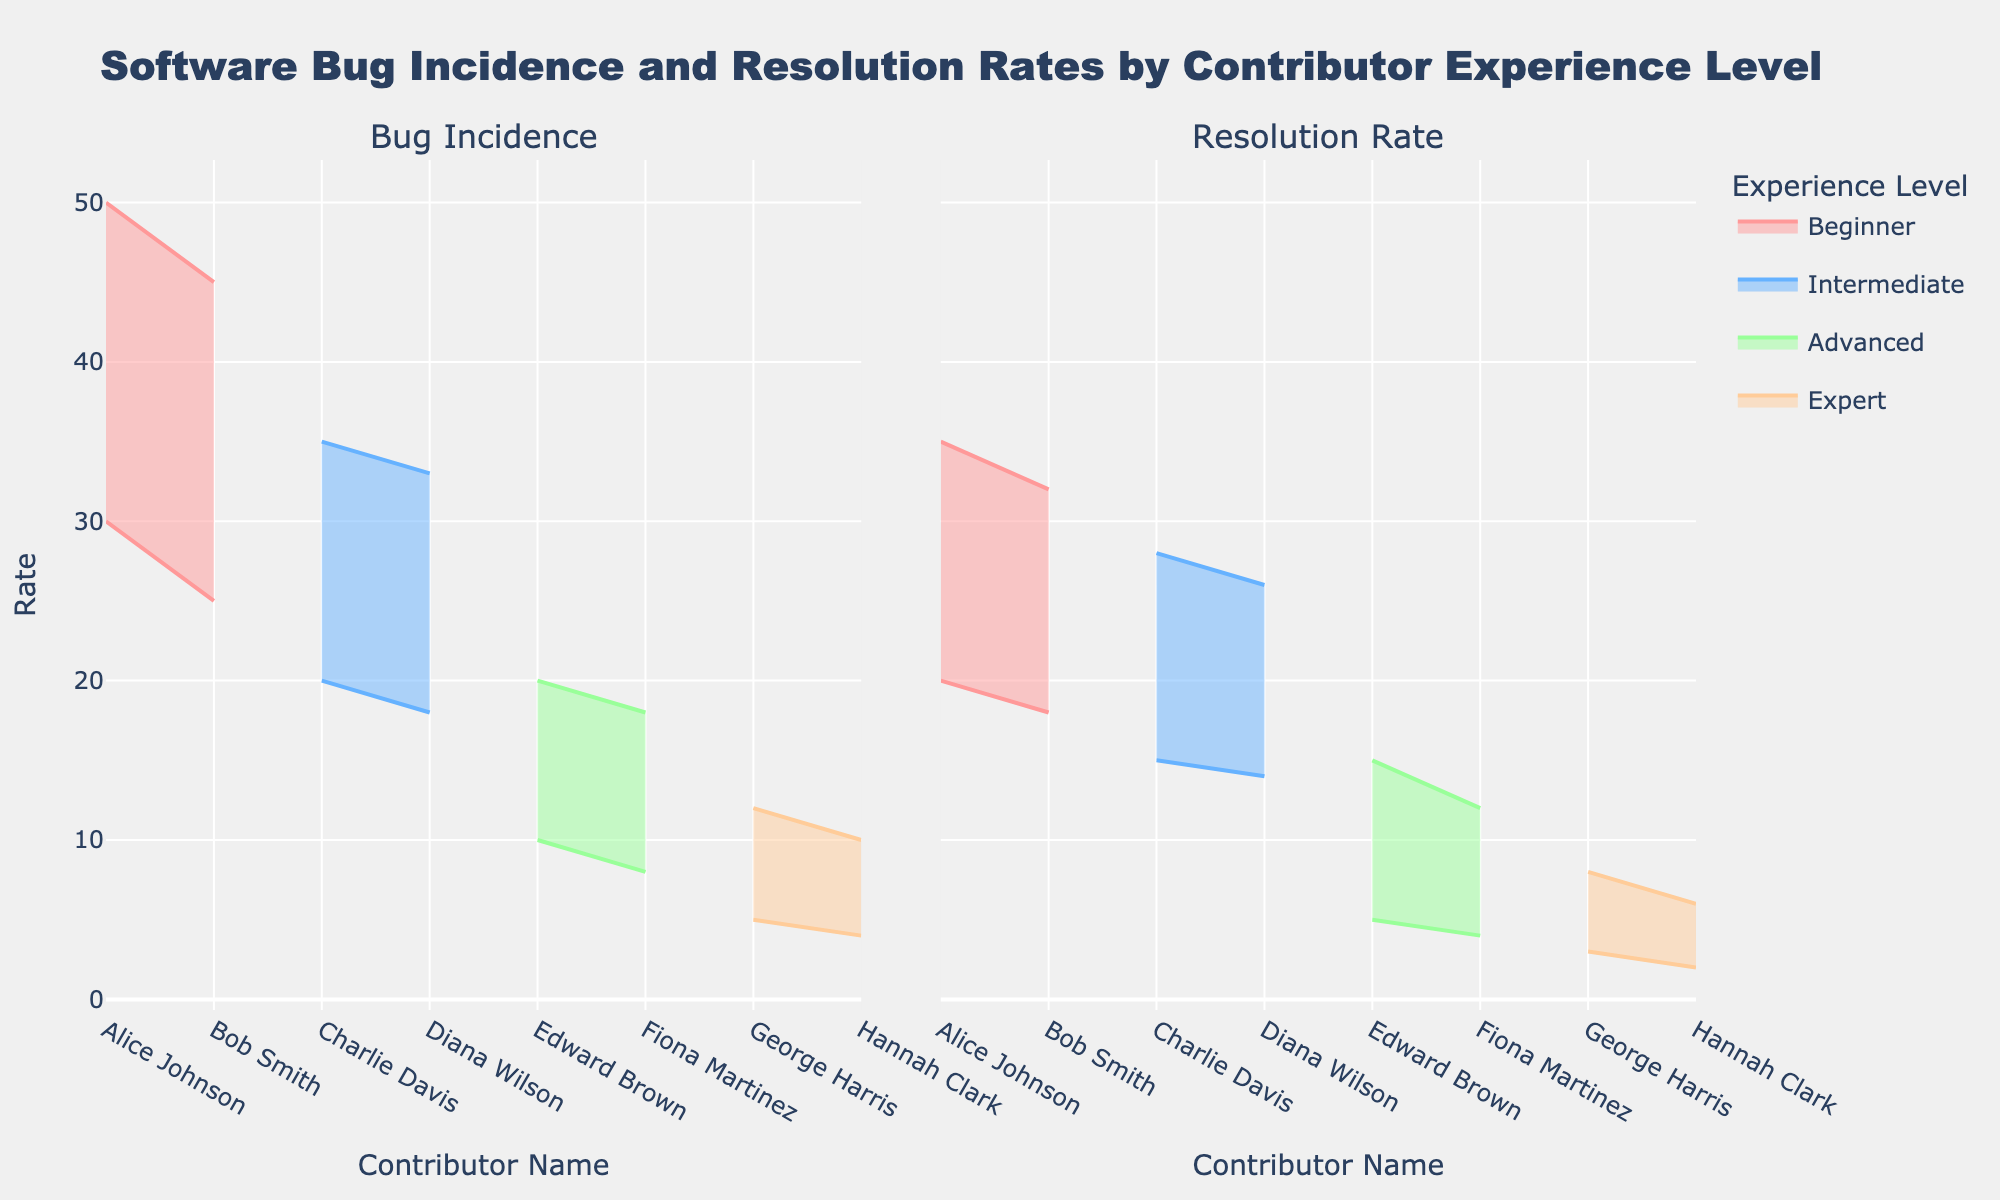What is the title of the figure? The title of the figure is found at the top center of the plot and usually summarizes the content in a concise manner. The title of this figure is "Software Bug Incidence and Resolution Rates by Contributor Experience Level".
Answer: Software Bug Incidence and Resolution Rates by Contributor Experience Level How many contributors are in the Intermediate experience level? The figure shows the contributors grouped by their experience levels, which are indicated in the legend. By looking at the Intermediate group on the plot, we can count the contributors. There are two contributors: Charlie Davis and Diana Wilson.
Answer: 2 Which contributor has the lowest upper rate of bug resolution in the Expert category? To find this, look at the Resolution Rate subplot for the Expert experience level and identify which contributor has the lowest upper limit in the shaded region. Hannah Clark has an upper resolution rate of 6, whereas George Harris has an upper limit of 8, so Hannah Clark has the lowest.
Answer: Hannah Clark What is the range of bug incidence rates for Beginner contributors? The range is determined by the difference between the upper and lower limits of the incidence rates for all contributors in the Beginner level. For Alice Johnson, the range is 50 - 30 = 20, and for Bob Smith, it is 45 - 25 = 20. Therefore, the range for both is 20.
Answer: 20 Which experience level has the smallest range of bug incidence rates? By examining the heights of the shaded areas in the Bug Incidence subplot for each experience level, we can see that the Expert level ("George Harris" and "Hannah Clark") has the smallest range: the individual ranges are 7 and 6, respectively. Therefore, the smallest range is for the Expert level.
Answer: Expert Is there any contributor whose lower limit of bug resolution rate is higher than any other contributor's upper limit in the same level? To answer this, we need to check each experience level's contributors' lower limits against their peers' upper limits. No contributor's lower limit exceeds another's upper limit within the same experience level. All contributors within the same level have overlapping ranges.
Answer: No Who has the widest range of bug resolution rates, and what is that range? The range for each contributor is the difference between their upper and lower resolution rates. For Alice Johnson, it's 35 - 20 = 15, for Bob Smith, it's 32 - 18 = 14, for Charlie Davis, it's 28 - 15 = 13, for Diana Wilson, it's 26 - 14 = 12, for Edward Brown, it's 15 - 5 = 10, for Fiona Martinez, it's 12 - 4 = 8, for George Harris, it's 8 - 3 = 5, and for Hannah Clark, it's 6 - 2 = 4. Alice Johnson has the widest range of 15.
Answer: Alice Johnson, 15 How does the range of incidence rates for Intermediate contributors compare to that of Advanced contributors? For Intermediate contributors, Charlie Davis has a range of 35 - 20 = 15 and Diana Wilson has a range of 33 - 18 = 15, averaging to 15. For Advanced contributors, Edward Brown has a range of 20 - 10 = 10 and Fiona Martinez has a range of 18 - 8 = 10, averaging to 10. Intermediate contributors have a wider average range of incidence rates compared to Advanced contributors.
Answer: Intermediate > Advanced Which contributor has the highest incidence upper limit? By checking the Bug Incidence subplot and examining the upper limits for all contributors, Alice Johnson has the highest upper limit at 50.
Answer: Alice Johnson 